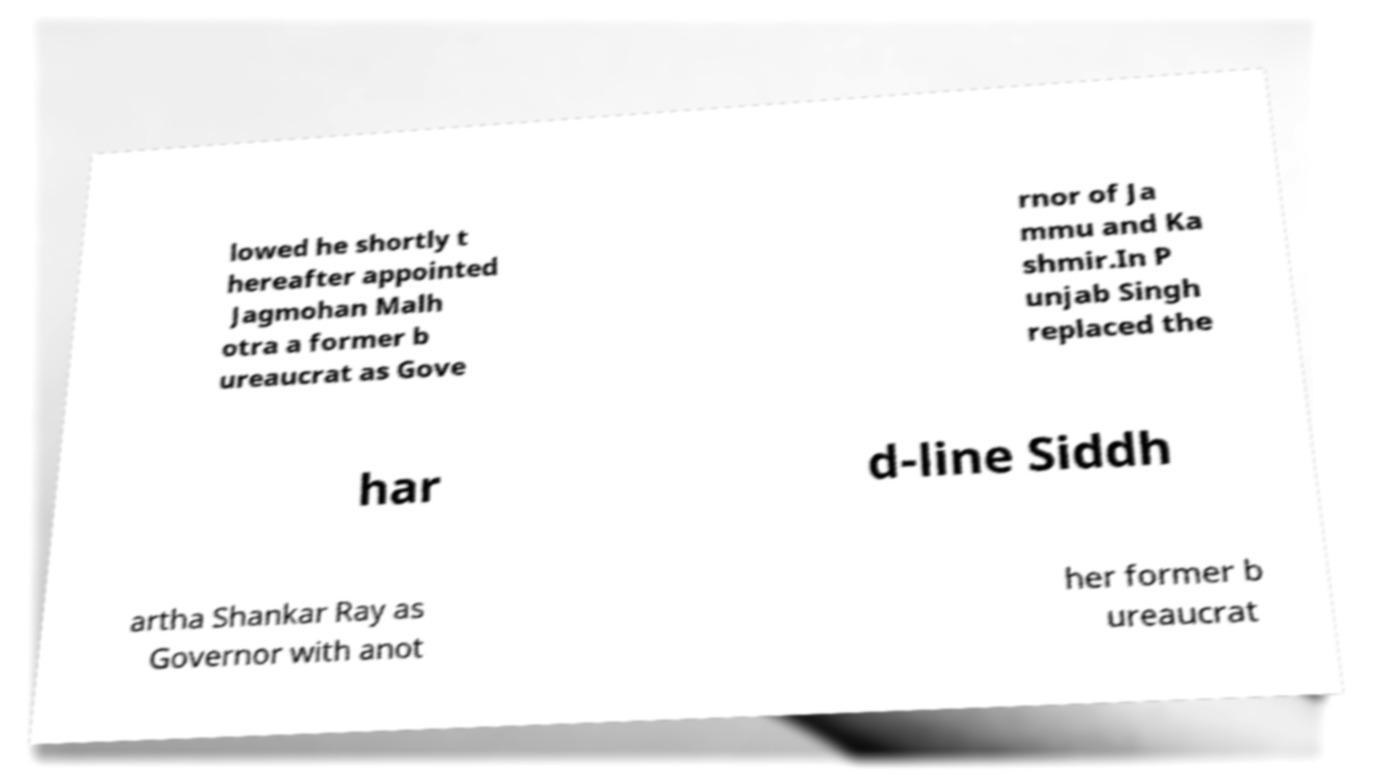There's text embedded in this image that I need extracted. Can you transcribe it verbatim? lowed he shortly t hereafter appointed Jagmohan Malh otra a former b ureaucrat as Gove rnor of Ja mmu and Ka shmir.In P unjab Singh replaced the har d-line Siddh artha Shankar Ray as Governor with anot her former b ureaucrat 